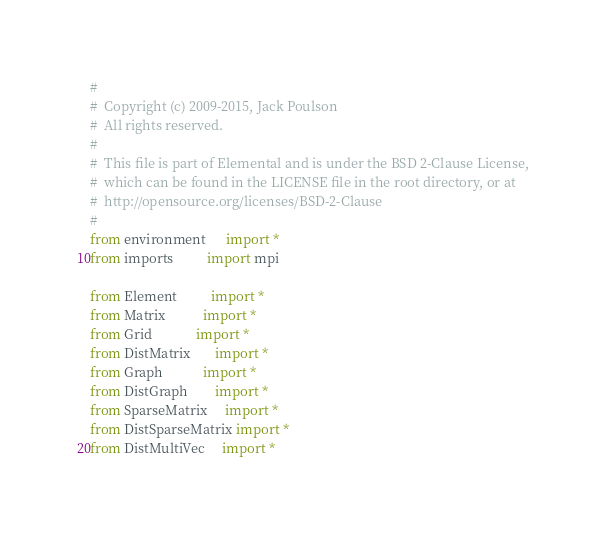<code> <loc_0><loc_0><loc_500><loc_500><_Python_>#
#  Copyright (c) 2009-2015, Jack Poulson
#  All rights reserved.
#
#  This file is part of Elemental and is under the BSD 2-Clause License, 
#  which can be found in the LICENSE file in the root directory, or at 
#  http://opensource.org/licenses/BSD-2-Clause
#
from environment      import *
from imports          import mpi

from Element          import *
from Matrix           import *
from Grid             import *
from DistMatrix       import *
from Graph            import *
from DistGraph        import *
from SparseMatrix     import *
from DistSparseMatrix import *
from DistMultiVec     import *
</code> 